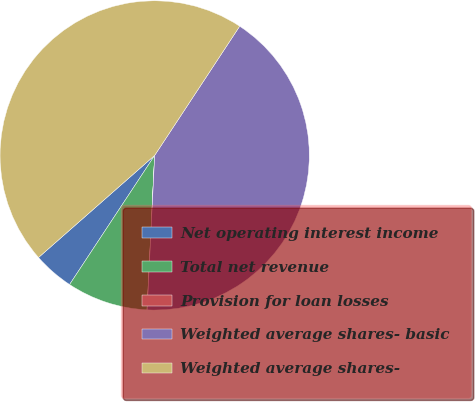Convert chart. <chart><loc_0><loc_0><loc_500><loc_500><pie_chart><fcel>Net operating interest income<fcel>Total net revenue<fcel>Provision for loan losses<fcel>Weighted average shares- basic<fcel>Weighted average shares-<nl><fcel>4.25%<fcel>8.48%<fcel>0.02%<fcel>41.51%<fcel>45.74%<nl></chart> 